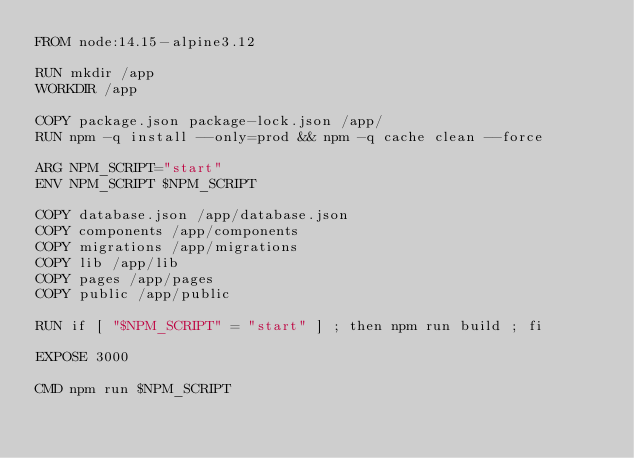<code> <loc_0><loc_0><loc_500><loc_500><_Dockerfile_>FROM node:14.15-alpine3.12

RUN mkdir /app
WORKDIR /app

COPY package.json package-lock.json /app/
RUN npm -q install --only=prod && npm -q cache clean --force

ARG NPM_SCRIPT="start"
ENV NPM_SCRIPT $NPM_SCRIPT

COPY database.json /app/database.json
COPY components /app/components
COPY migrations /app/migrations
COPY lib /app/lib
COPY pages /app/pages
COPY public /app/public

RUN if [ "$NPM_SCRIPT" = "start" ] ; then npm run build ; fi

EXPOSE 3000

CMD npm run $NPM_SCRIPT</code> 